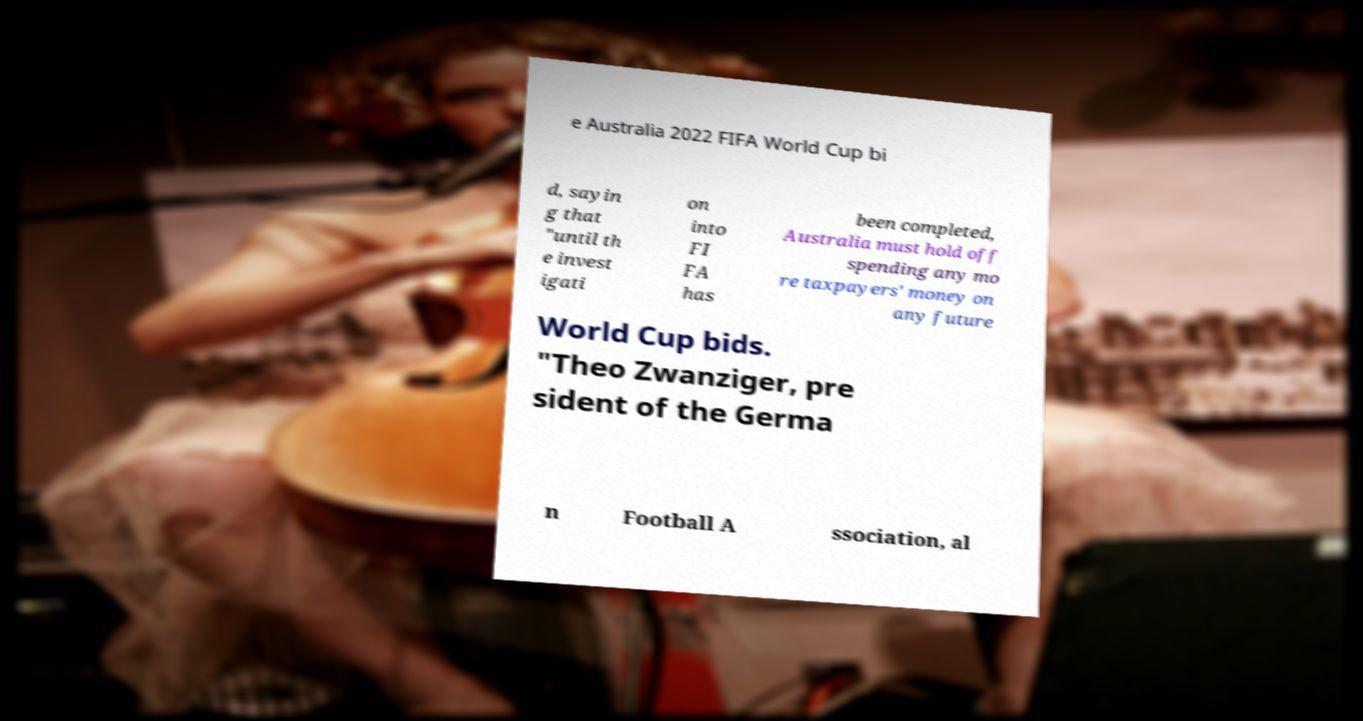I need the written content from this picture converted into text. Can you do that? e Australia 2022 FIFA World Cup bi d, sayin g that "until th e invest igati on into FI FA has been completed, Australia must hold off spending any mo re taxpayers' money on any future World Cup bids. "Theo Zwanziger, pre sident of the Germa n Football A ssociation, al 